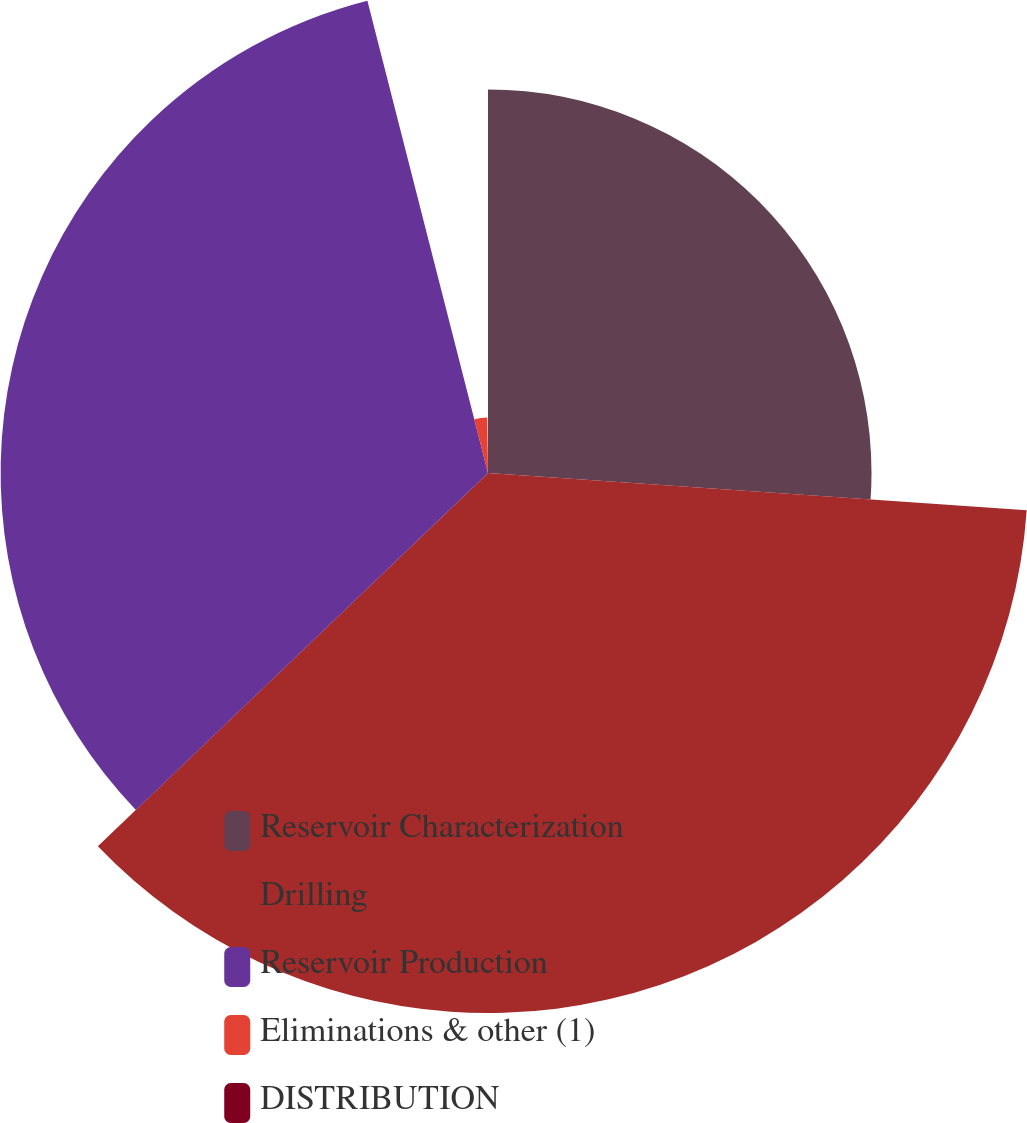Convert chart. <chart><loc_0><loc_0><loc_500><loc_500><pie_chart><fcel>Reservoir Characterization<fcel>Drilling<fcel>Reservoir Production<fcel>Eliminations & other (1)<fcel>DISTRIBUTION<nl><fcel>26.1%<fcel>36.75%<fcel>33.17%<fcel>3.78%<fcel>0.2%<nl></chart> 